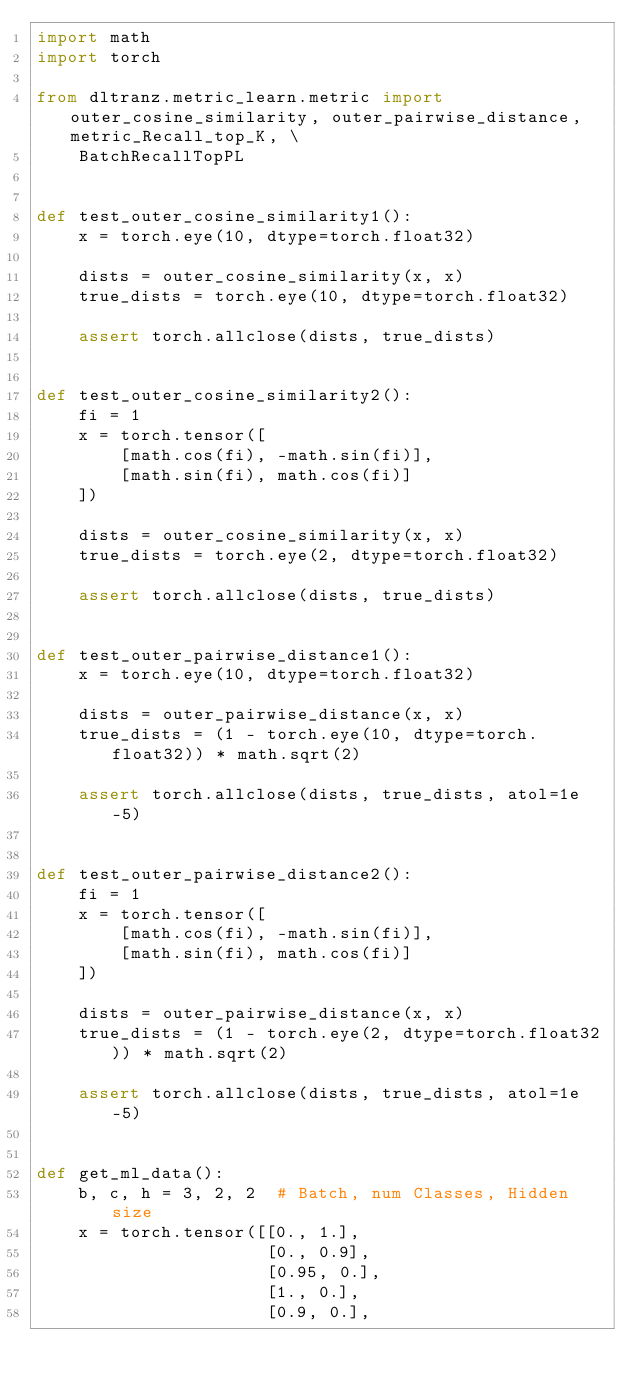<code> <loc_0><loc_0><loc_500><loc_500><_Python_>import math
import torch

from dltranz.metric_learn.metric import outer_cosine_similarity, outer_pairwise_distance, metric_Recall_top_K, \
    BatchRecallTopPL


def test_outer_cosine_similarity1():
    x = torch.eye(10, dtype=torch.float32)

    dists = outer_cosine_similarity(x, x)
    true_dists = torch.eye(10, dtype=torch.float32)

    assert torch.allclose(dists, true_dists)


def test_outer_cosine_similarity2():
    fi = 1
    x = torch.tensor([
        [math.cos(fi), -math.sin(fi)],
        [math.sin(fi), math.cos(fi)]
    ])

    dists = outer_cosine_similarity(x, x)
    true_dists = torch.eye(2, dtype=torch.float32)

    assert torch.allclose(dists, true_dists)


def test_outer_pairwise_distance1():
    x = torch.eye(10, dtype=torch.float32)

    dists = outer_pairwise_distance(x, x)
    true_dists = (1 - torch.eye(10, dtype=torch.float32)) * math.sqrt(2)

    assert torch.allclose(dists, true_dists, atol=1e-5)


def test_outer_pairwise_distance2():
    fi = 1
    x = torch.tensor([
        [math.cos(fi), -math.sin(fi)],
        [math.sin(fi), math.cos(fi)]
    ])

    dists = outer_pairwise_distance(x, x)
    true_dists = (1 - torch.eye(2, dtype=torch.float32)) * math.sqrt(2)

    assert torch.allclose(dists, true_dists, atol=1e-5)


def get_ml_data():
    b, c, h = 3, 2, 2  # Batch, num Classes, Hidden size
    x = torch.tensor([[0., 1.],
                      [0., 0.9],
                      [0.95, 0.],
                      [1., 0.],
                      [0.9, 0.],</code> 